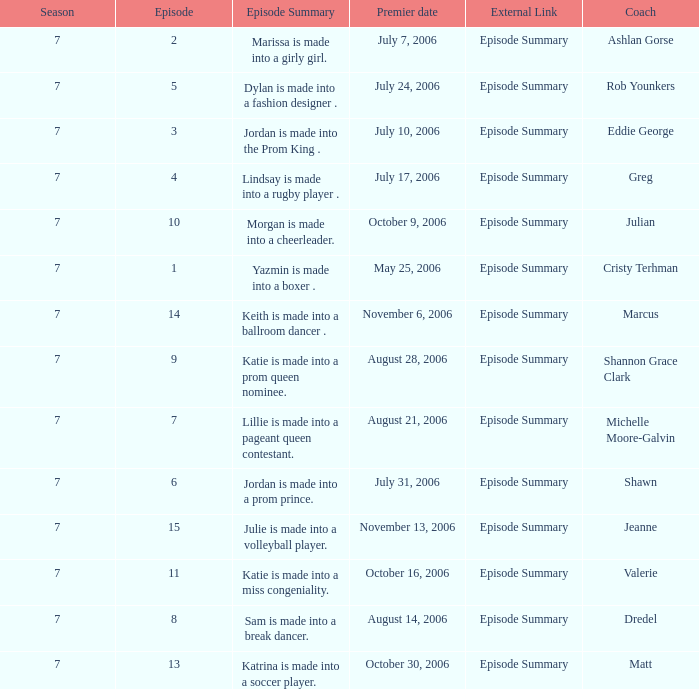What is the newest season? 7.0. 